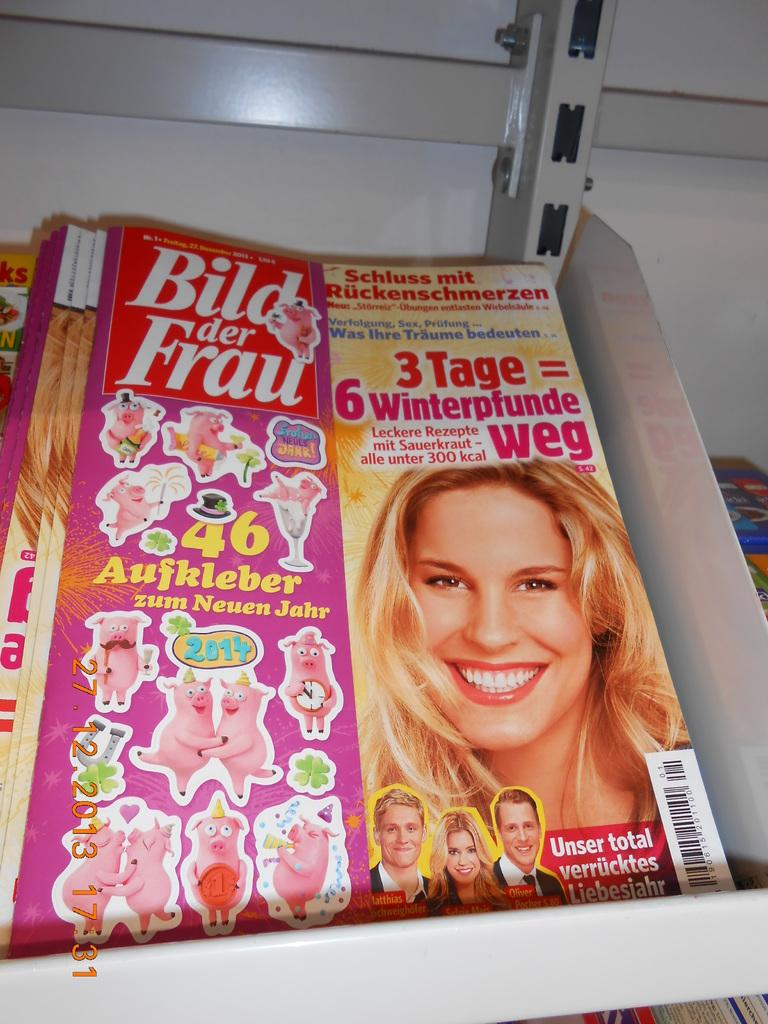What type of storage or display system is present in the image? There are iron racks in the image. What items are placed on the iron racks? There are magazines in the image. What type of chin is visible on the magazine cover in the image? There is no chin visible in the image, as it features iron racks with magazines and does not show any magazine covers. 